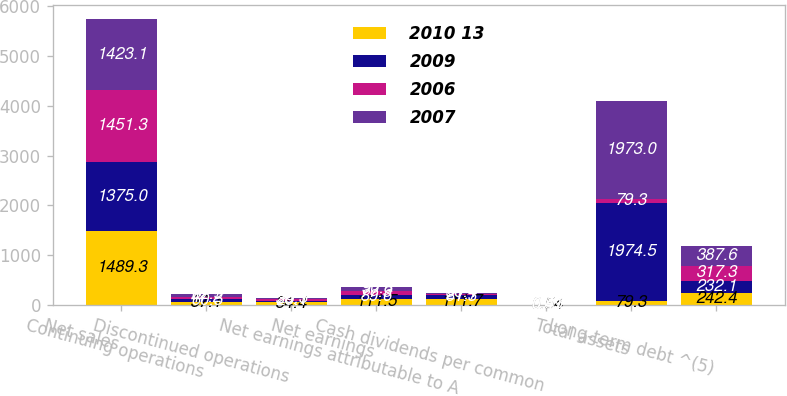Convert chart to OTSL. <chart><loc_0><loc_0><loc_500><loc_500><stacked_bar_chart><ecel><fcel>Net sales<fcel>Continuing operations<fcel>Discontinued operations<fcel>Net earnings<fcel>Net earnings attributable to A<fcel>Cash dividends per common<fcel>Total assets<fcel>Long-term debt ^(5)<nl><fcel>2010 13<fcel>1489.3<fcel>57.1<fcel>54.4<fcel>111.5<fcel>111.7<fcel>0.54<fcel>79.3<fcel>242.4<nl><fcel>2009<fcel>1375<fcel>60.5<fcel>29.1<fcel>89.6<fcel>81.3<fcel>0.51<fcel>1974.5<fcel>232.1<nl><fcel>2006<fcel>1451.3<fcel>47.2<fcel>30.1<fcel>77.3<fcel>21.7<fcel>0.49<fcel>79.3<fcel>317.3<nl><fcel>2007<fcel>1423.1<fcel>62.5<fcel>28.3<fcel>90.8<fcel>30.4<fcel>0.47<fcel>1973<fcel>387.6<nl></chart> 